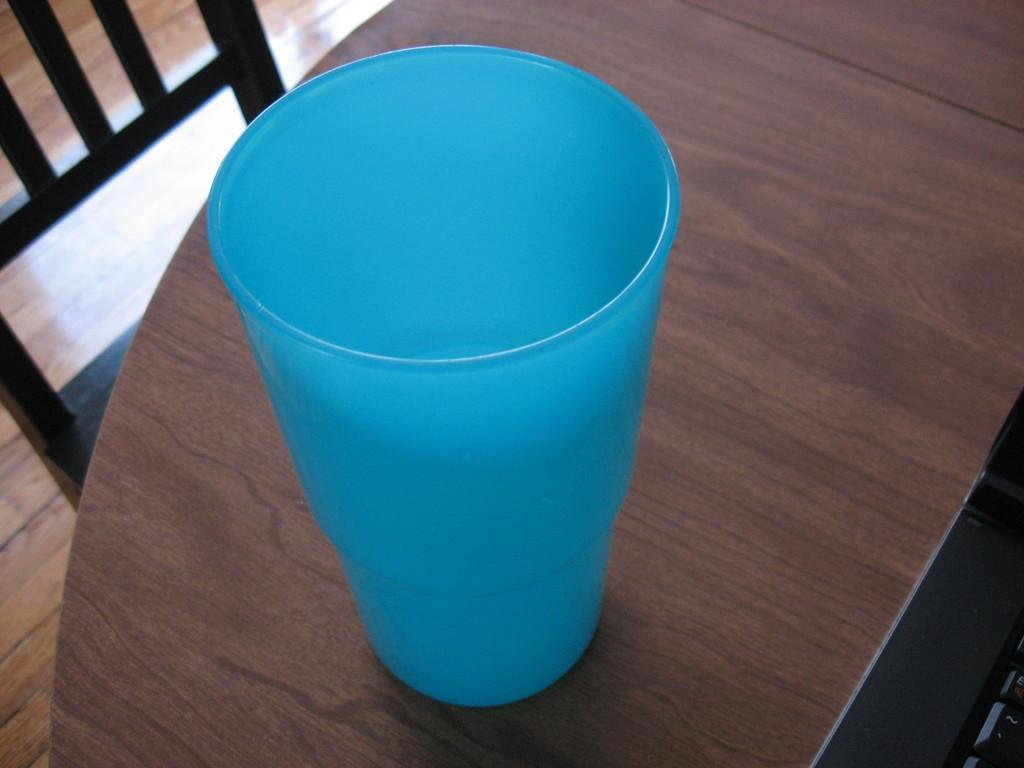What can be seen in the image that resembles a device? There is a device in the image. What is placed on the table in the image? There is a glass on a table in the image. What type of furniture is visible in the image? There is a chair visible in the image. What is the surface on which the table and chair are placed? There is a floor in the image. Can you see any ants crawling on the device in the image? There are no ants present in the image. What causes the device to burst in the image? The device does not burst in the image; it is stationary and intact. 